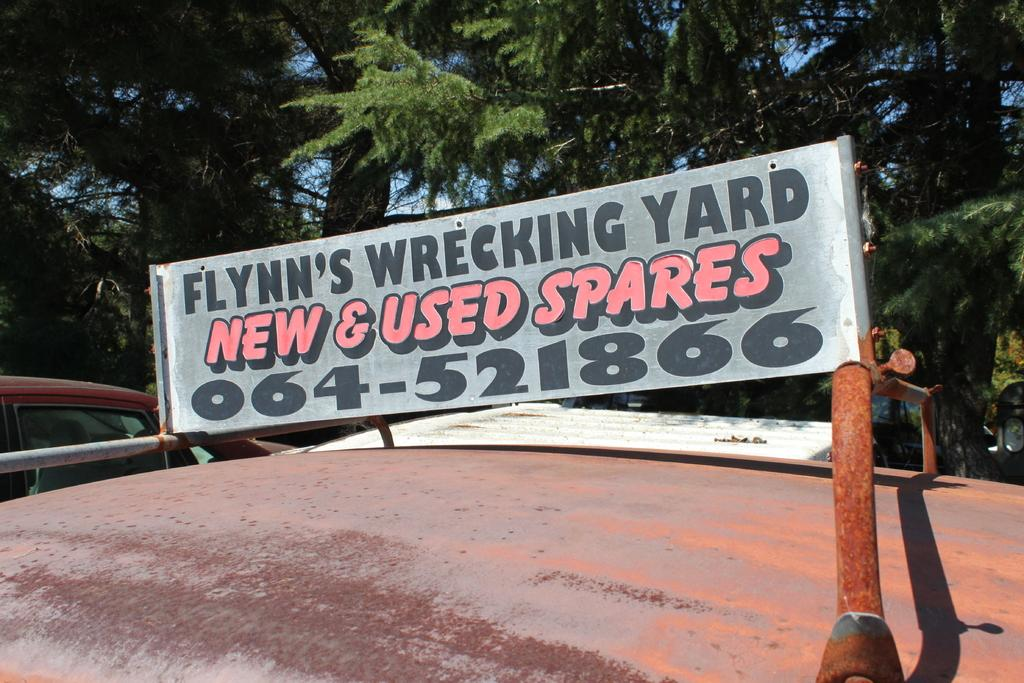What is on the car in the image? There is an advertisement board on a car in the image. Can you describe the background of the image? There is a car and trees in the background of the image, and the sky is visible as well. What type of story is being told by the sponge in the image? There is no sponge present in the image, so no story can be told by a sponge. 